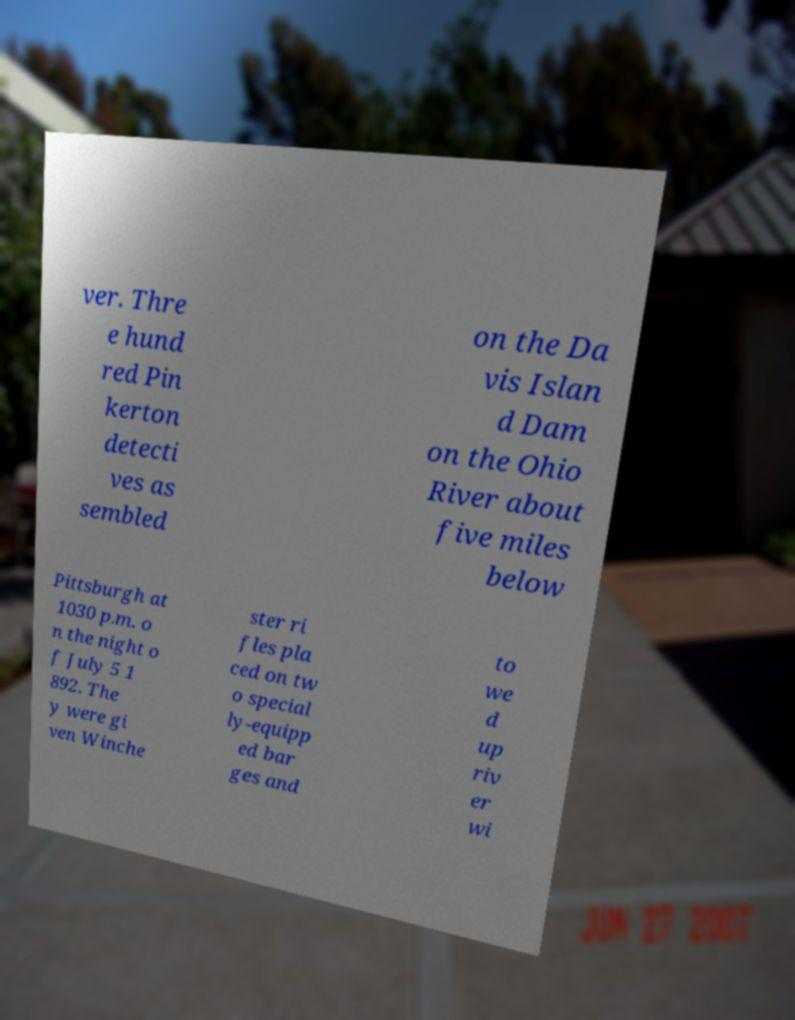Could you extract and type out the text from this image? ver. Thre e hund red Pin kerton detecti ves as sembled on the Da vis Islan d Dam on the Ohio River about five miles below Pittsburgh at 1030 p.m. o n the night o f July 5 1 892. The y were gi ven Winche ster ri fles pla ced on tw o special ly-equipp ed bar ges and to we d up riv er wi 